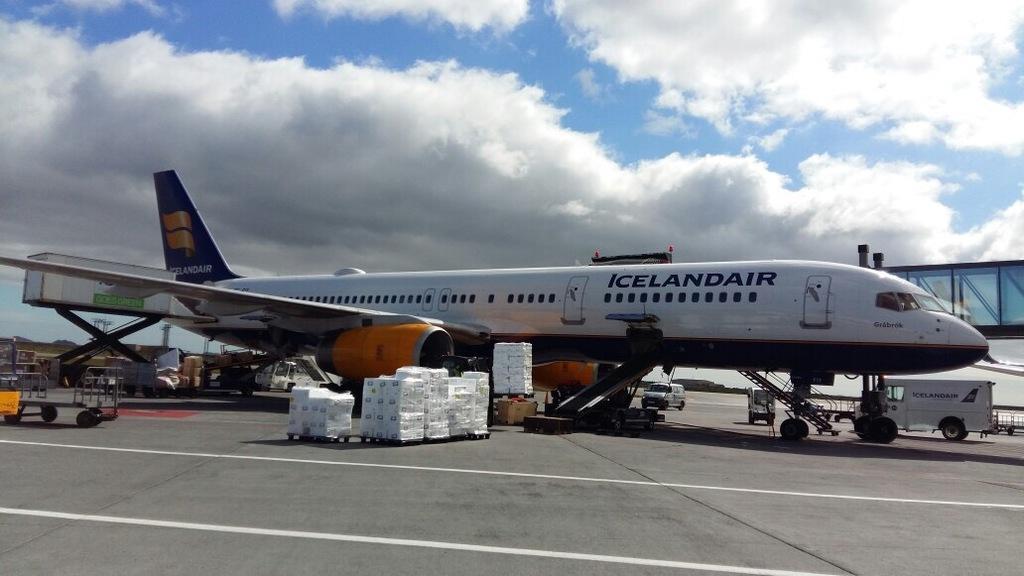Who owns this airlines?
Offer a terse response. Icelandair. 